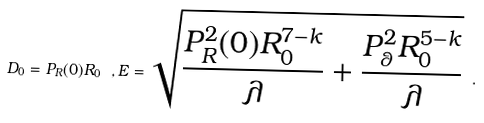<formula> <loc_0><loc_0><loc_500><loc_500>D _ { 0 } = P _ { R } ( 0 ) R _ { 0 } \ , E = \sqrt { \frac { P _ { R } ^ { 2 } ( 0 ) R ^ { 7 - k } _ { 0 } } { \lambda } + \frac { P ^ { 2 } _ { \theta } R ^ { 5 - k } _ { 0 } } { \lambda } } \ .</formula> 